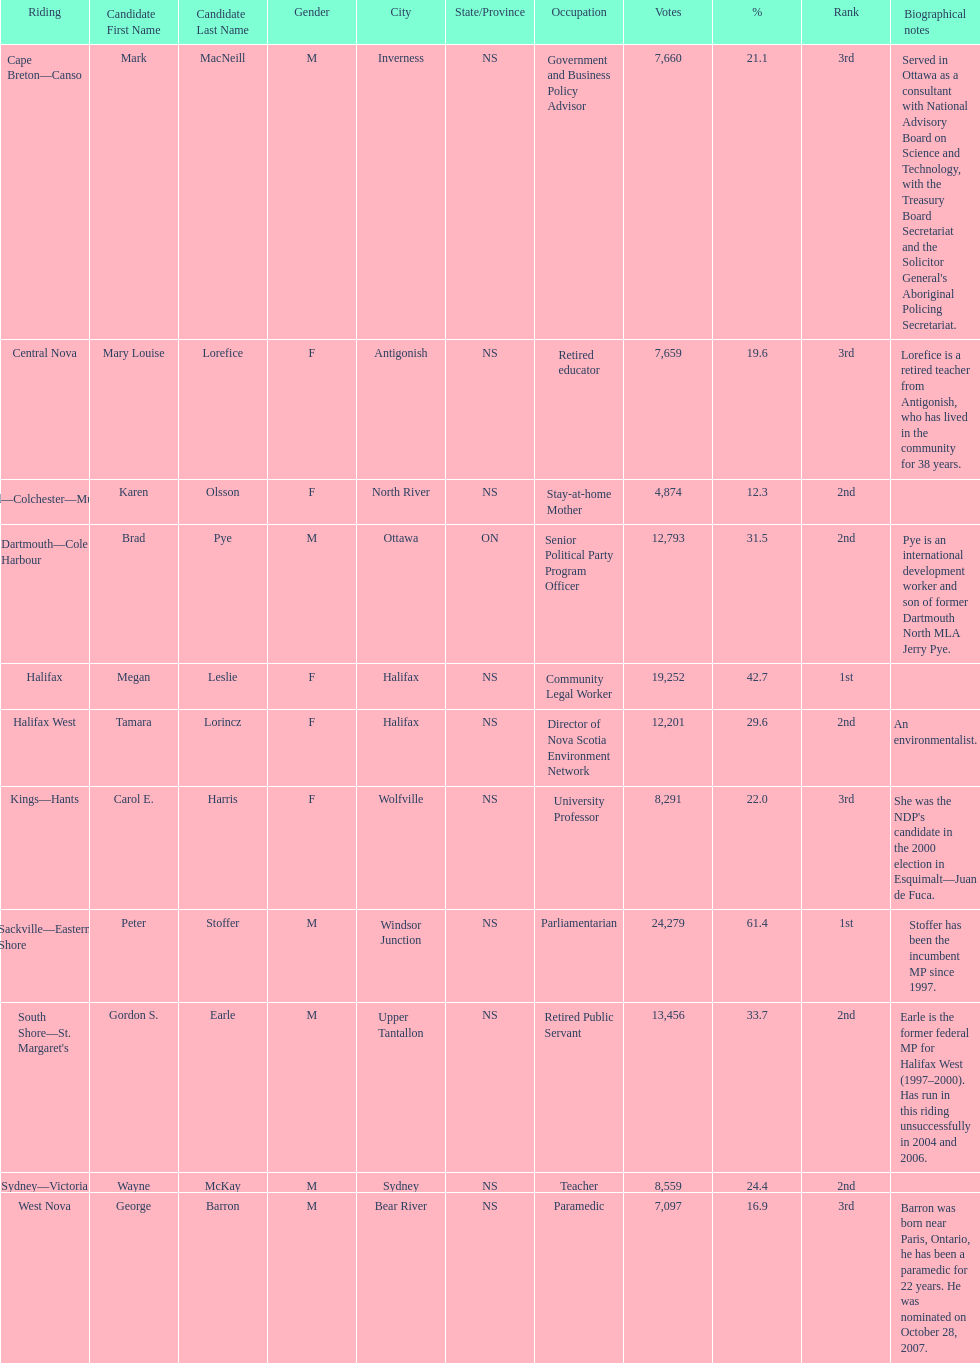Could you parse the entire table as a dict? {'header': ['Riding', 'Candidate First Name', 'Candidate Last Name', 'Gender', 'City', 'State/Province', 'Occupation', 'Votes', '%', 'Rank', 'Biographical notes'], 'rows': [['Cape Breton—Canso', 'Mark', 'MacNeill', 'M', 'Inverness', 'NS', 'Government and Business Policy Advisor', '7,660', '21.1', '3rd', "Served in Ottawa as a consultant with National Advisory Board on Science and Technology, with the Treasury Board Secretariat and the Solicitor General's Aboriginal Policing Secretariat."], ['Central Nova', 'Mary Louise', 'Lorefice', 'F', 'Antigonish', 'NS', 'Retired educator', '7,659', '19.6', '3rd', 'Lorefice is a retired teacher from Antigonish, who has lived in the community for 38 years.'], ['Cumberland—Colchester—Musquodoboit Valley', 'Karen', 'Olsson', 'F', 'North River', 'NS', 'Stay-at-home Mother', '4,874', '12.3', '2nd', ''], ['Dartmouth—Cole Harbour', 'Brad', 'Pye', 'M', 'Ottawa', 'ON', 'Senior Political Party Program Officer', '12,793', '31.5', '2nd', 'Pye is an international development worker and son of former Dartmouth North MLA Jerry Pye.'], ['Halifax', 'Megan', 'Leslie', 'F', 'Halifax', 'NS', 'Community Legal Worker', '19,252', '42.7', '1st', ''], ['Halifax West', 'Tamara', 'Lorincz', 'F', 'Halifax', 'NS', 'Director of Nova Scotia Environment Network', '12,201', '29.6', '2nd', 'An environmentalist.'], ['Kings—Hants', 'Carol E.', 'Harris', 'F', 'Wolfville', 'NS', 'University Professor', '8,291', '22.0', '3rd', "She was the NDP's candidate in the 2000 election in Esquimalt—Juan de Fuca."], ['Sackville—Eastern Shore', 'Peter', 'Stoffer', 'M', 'Windsor Junction', 'NS', 'Parliamentarian', '24,279', '61.4', '1st', 'Stoffer has been the incumbent MP since 1997.'], ["South Shore—St. Margaret's", 'Gordon S.', 'Earle', 'M', 'Upper Tantallon', 'NS', 'Retired Public Servant', '13,456', '33.7', '2nd', 'Earle is the former federal MP for Halifax West (1997–2000). Has run in this riding unsuccessfully in 2004 and 2006.'], ['Sydney—Victoria', 'Wayne', 'McKay', 'M', 'Sydney', 'NS', 'Teacher', '8,559', '24.4', '2nd', ''], ['West Nova', 'George', 'Barron', 'M', 'Bear River', 'NS', 'Paramedic', '7,097', '16.9', '3rd', 'Barron was born near Paris, Ontario, he has been a paramedic for 22 years. He was nominated on October 28, 2007.']]} What is the number of votes that megan leslie received? 19,252. 